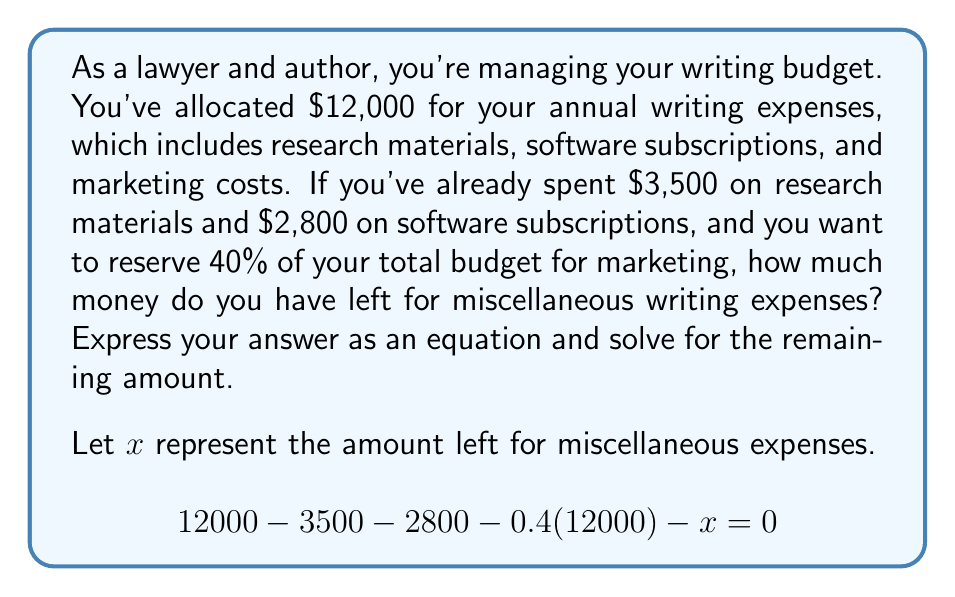Give your solution to this math problem. Let's solve this equation step by step:

1) First, we'll simplify the known expenses:
   $$12000 - 3500 - 2800 - 0.4(12000) - x = 0$$

2) Calculate 40% of the total budget:
   $0.4(12000) = 4800$

3) Substitute this value into the equation:
   $$12000 - 3500 - 2800 - 4800 - x = 0$$

4) Simplify the left side of the equation:
   $$900 - x = 0$$

5) Add $x$ to both sides:
   $$900 = x$$

Therefore, the amount left for miscellaneous writing expenses is $900.

To verify:
- Research materials: $3500
- Software subscriptions: $2800
- Marketing (40% of $12000): $4800
- Miscellaneous: $900

Total: $3500 + $2800 + $4800 + $900 = $12000

This matches the original budget, confirming our solution.
Answer: $x = 900$

The amount left for miscellaneous writing expenses is $900. 